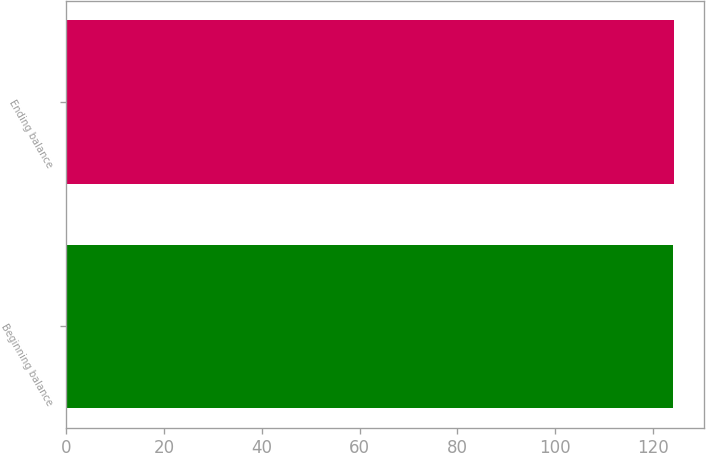Convert chart. <chart><loc_0><loc_0><loc_500><loc_500><bar_chart><fcel>Beginning balance<fcel>Ending balance<nl><fcel>124.1<fcel>124.2<nl></chart> 